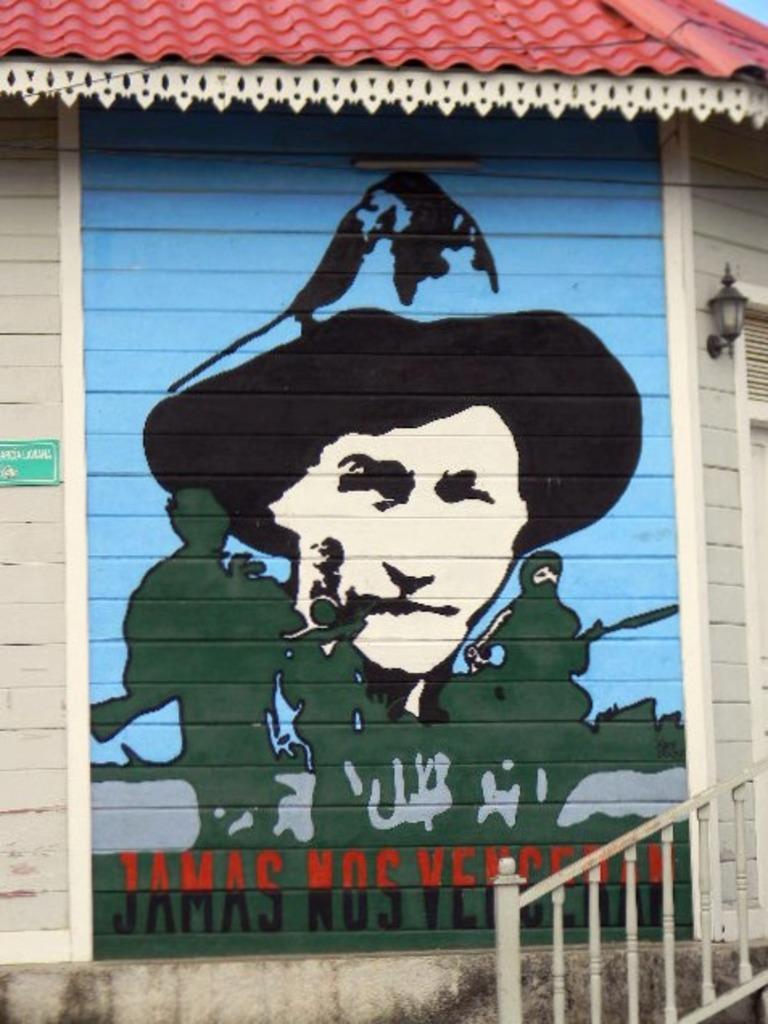Can you describe this image briefly? In this image, we can see a wall, on that wall there is a painting and at the right side there are some stairs and there is white color railing. 